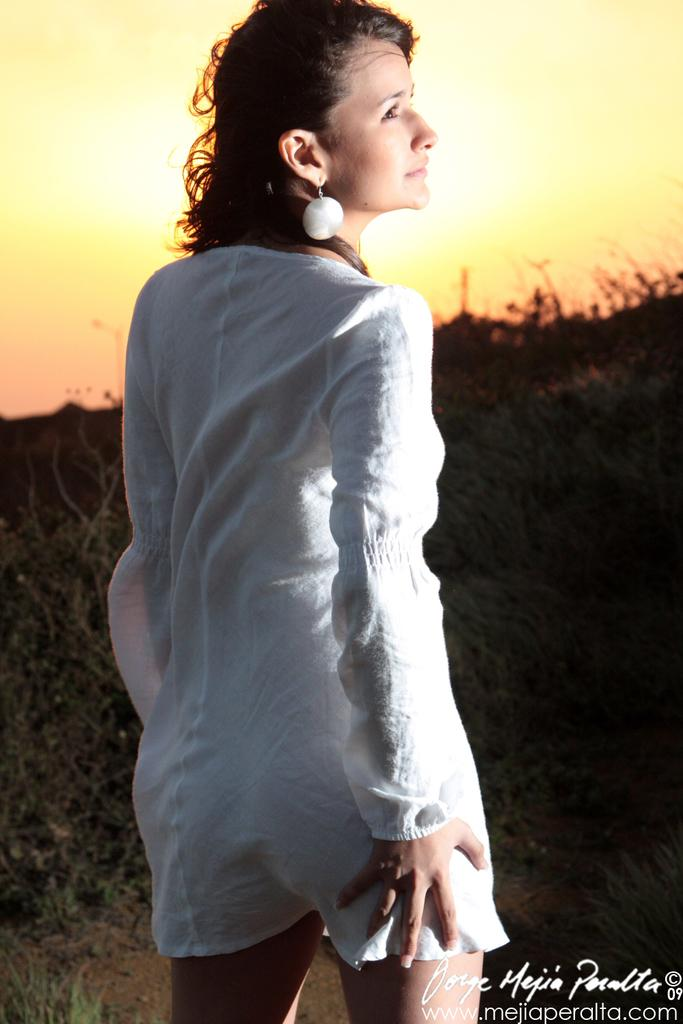What is the main subject of the image? There is a woman standing in the image. What is the woman wearing? The woman is wearing a white dress. What can be seen at the top of the image? The sky is visible at the top of the image. What is present at the bottom of the image? There is text at the bottom of the image. Can you hear the woman laughing in the image? There is no sound in the image, so it is not possible to hear the woman laughing. 